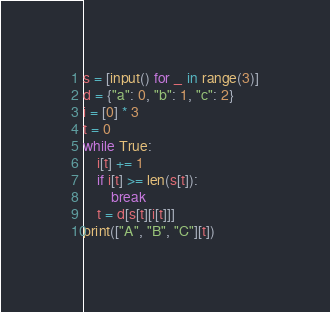Convert code to text. <code><loc_0><loc_0><loc_500><loc_500><_Python_>s = [input() for _ in range(3)]
d = {"a": 0, "b": 1, "c": 2}
i = [0] * 3
t = 0
while True:
    i[t] += 1
    if i[t] >= len(s[t]):
        break
    t = d[s[t][i[t]]]
print(["A", "B", "C"][t])</code> 